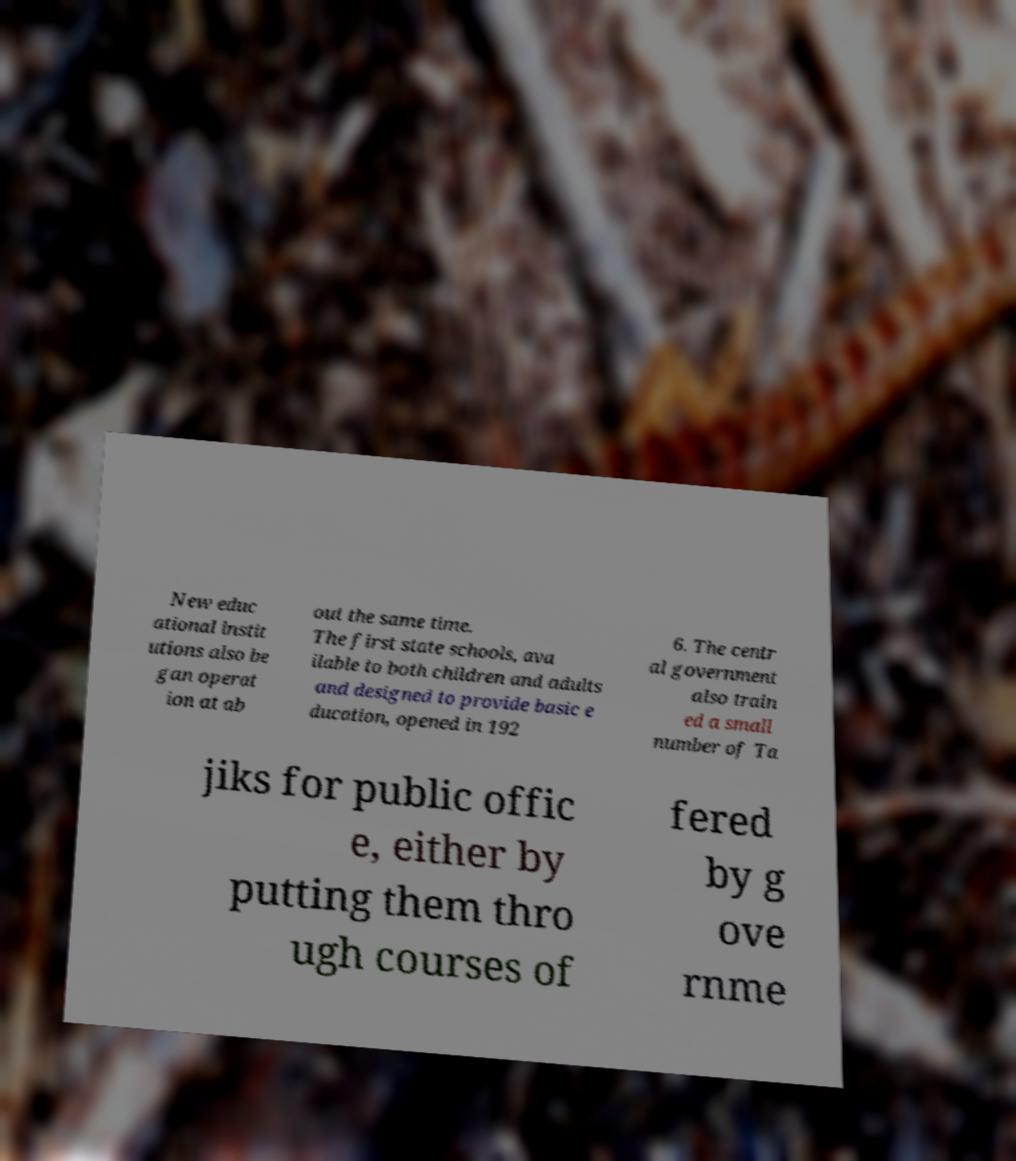There's text embedded in this image that I need extracted. Can you transcribe it verbatim? New educ ational instit utions also be gan operat ion at ab out the same time. The first state schools, ava ilable to both children and adults and designed to provide basic e ducation, opened in 192 6. The centr al government also train ed a small number of Ta jiks for public offic e, either by putting them thro ugh courses of fered by g ove rnme 